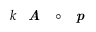<formula> <loc_0><loc_0><loc_500><loc_500>k A \circ p</formula> 